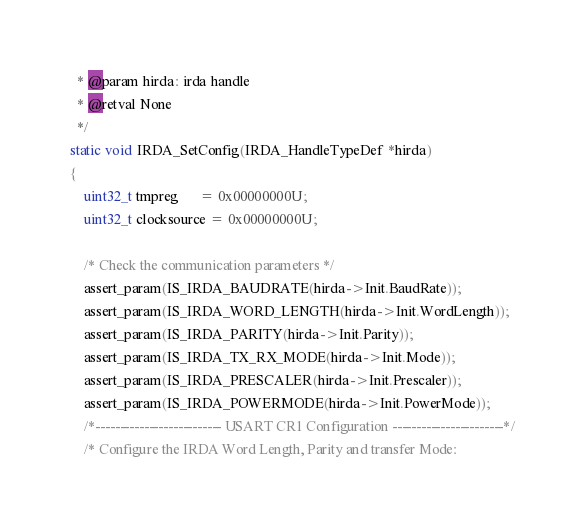<code> <loc_0><loc_0><loc_500><loc_500><_C_>  * @param hirda: irda handle
  * @retval None
  */
static void IRDA_SetConfig(IRDA_HandleTypeDef *hirda)
{
    uint32_t tmpreg      = 0x00000000U;
    uint32_t clocksource = 0x00000000U;

    /* Check the communication parameters */
    assert_param(IS_IRDA_BAUDRATE(hirda->Init.BaudRate));
    assert_param(IS_IRDA_WORD_LENGTH(hirda->Init.WordLength));
    assert_param(IS_IRDA_PARITY(hirda->Init.Parity));
    assert_param(IS_IRDA_TX_RX_MODE(hirda->Init.Mode));
    assert_param(IS_IRDA_PRESCALER(hirda->Init.Prescaler));
    assert_param(IS_IRDA_POWERMODE(hirda->Init.PowerMode));
    /*-------------------------- USART CR1 Configuration -----------------------*/
    /* Configure the IRDA Word Length, Parity and transfer Mode:</code> 